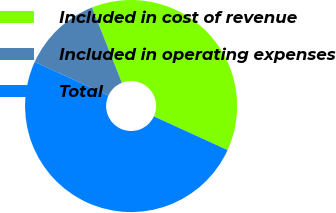<chart> <loc_0><loc_0><loc_500><loc_500><pie_chart><fcel>Included in cost of revenue<fcel>Included in operating expenses<fcel>Total<nl><fcel>37.84%<fcel>12.16%<fcel>50.0%<nl></chart> 